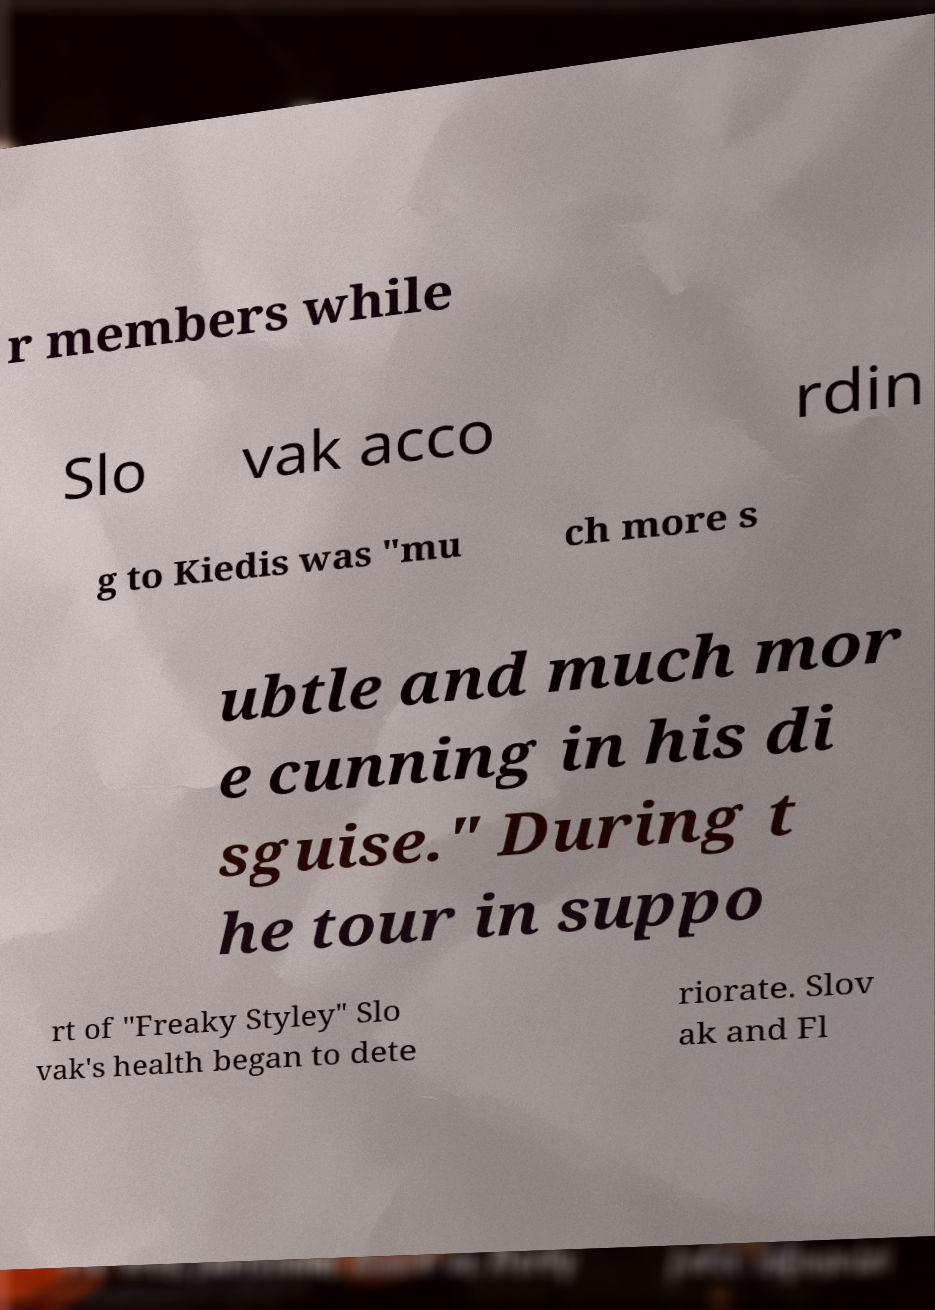Could you extract and type out the text from this image? r members while Slo vak acco rdin g to Kiedis was "mu ch more s ubtle and much mor e cunning in his di sguise." During t he tour in suppo rt of "Freaky Styley" Slo vak's health began to dete riorate. Slov ak and Fl 